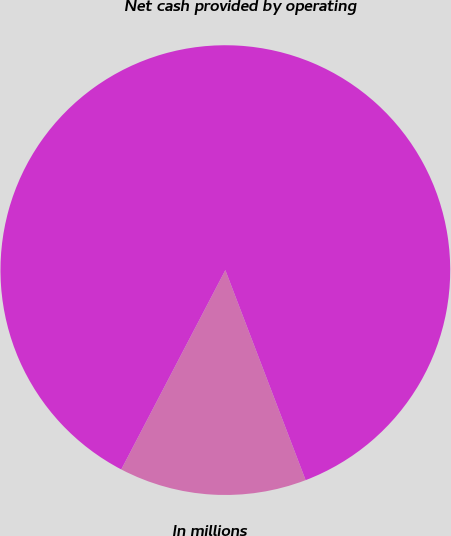Convert chart. <chart><loc_0><loc_0><loc_500><loc_500><pie_chart><fcel>In millions<fcel>Net cash provided by operating<nl><fcel>13.47%<fcel>86.53%<nl></chart> 